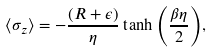<formula> <loc_0><loc_0><loc_500><loc_500>\langle \sigma _ { z } \rangle = - \frac { ( R + \epsilon ) } { \eta } \tanh { \left ( \frac { \beta \eta } { 2 } \right ) } ,</formula> 